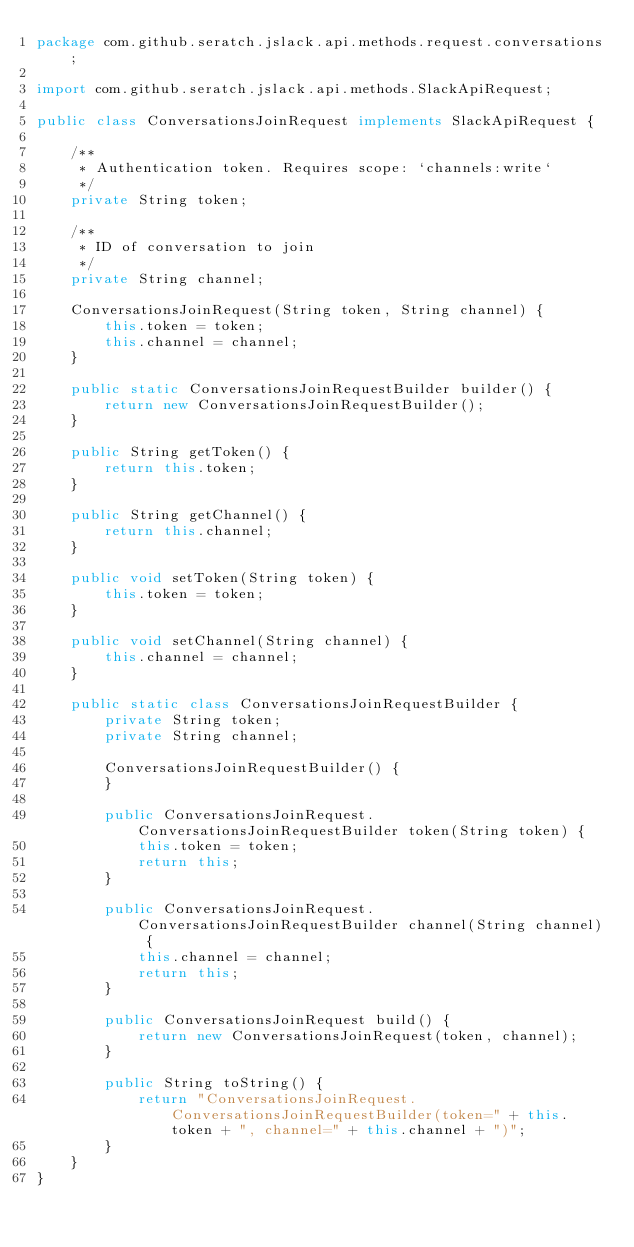Convert code to text. <code><loc_0><loc_0><loc_500><loc_500><_Java_>package com.github.seratch.jslack.api.methods.request.conversations;

import com.github.seratch.jslack.api.methods.SlackApiRequest;

public class ConversationsJoinRequest implements SlackApiRequest {

    /**
     * Authentication token. Requires scope: `channels:write`
     */
    private String token;

    /**
     * ID of conversation to join
     */
    private String channel;

    ConversationsJoinRequest(String token, String channel) {
        this.token = token;
        this.channel = channel;
    }

    public static ConversationsJoinRequestBuilder builder() {
        return new ConversationsJoinRequestBuilder();
    }

    public String getToken() {
        return this.token;
    }

    public String getChannel() {
        return this.channel;
    }

    public void setToken(String token) {
        this.token = token;
    }

    public void setChannel(String channel) {
        this.channel = channel;
    }

    public static class ConversationsJoinRequestBuilder {
        private String token;
        private String channel;

        ConversationsJoinRequestBuilder() {
        }

        public ConversationsJoinRequest.ConversationsJoinRequestBuilder token(String token) {
            this.token = token;
            return this;
        }

        public ConversationsJoinRequest.ConversationsJoinRequestBuilder channel(String channel) {
            this.channel = channel;
            return this;
        }

        public ConversationsJoinRequest build() {
            return new ConversationsJoinRequest(token, channel);
        }

        public String toString() {
            return "ConversationsJoinRequest.ConversationsJoinRequestBuilder(token=" + this.token + ", channel=" + this.channel + ")";
        }
    }
}
</code> 